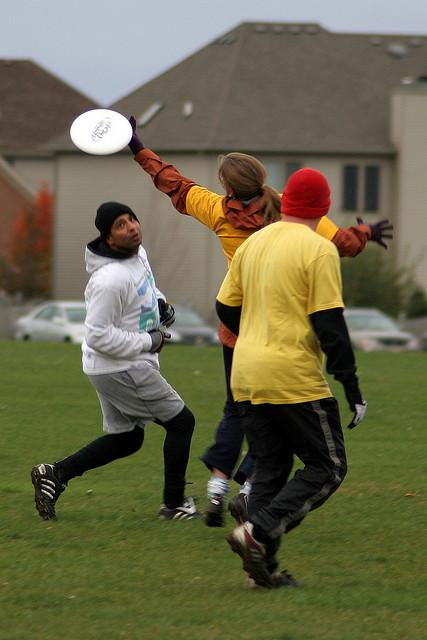What sport is being played? Please explain your reasoning. ultimate frisbee. There is a disk in the air. 